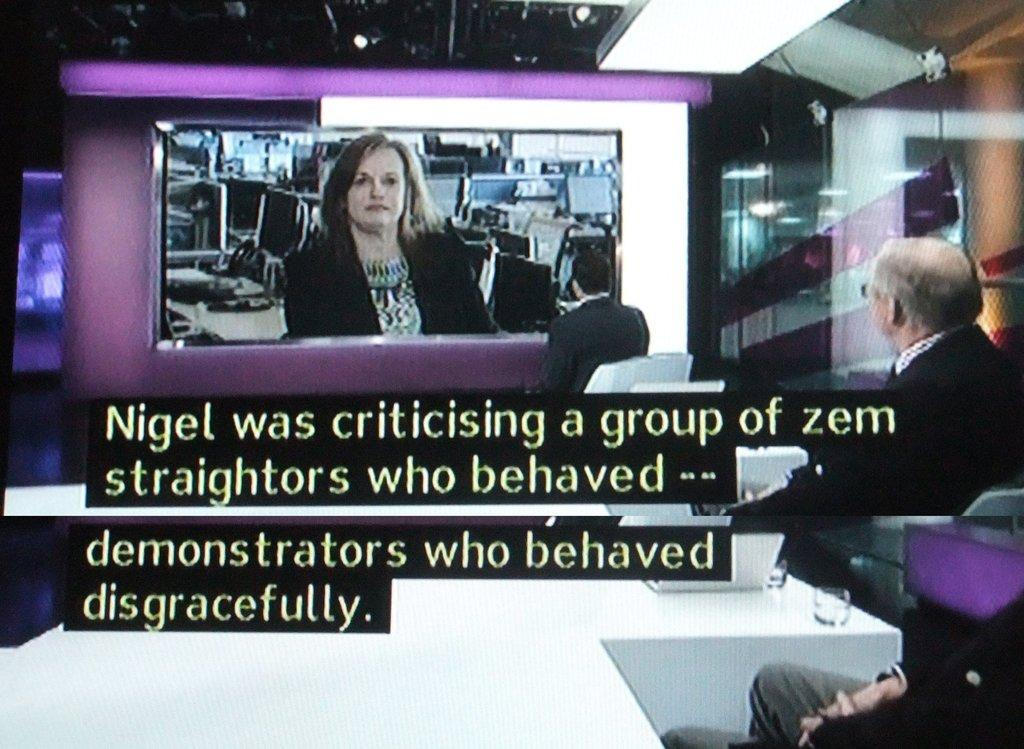<image>
Relay a brief, clear account of the picture shown. Two men at a desk look towards a screen with a woman on it who is talking about demonstrators behavior. 